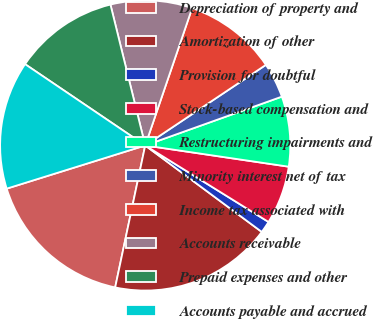<chart> <loc_0><loc_0><loc_500><loc_500><pie_chart><fcel>Depreciation of property and<fcel>Amortization of other<fcel>Provision for doubtful<fcel>Stock-based compensation and<fcel>Restructuring impairments and<fcel>Minority interest net of tax<fcel>Income tax associated with<fcel>Accounts receivable<fcel>Prepaid expenses and other<fcel>Accounts payable and accrued<nl><fcel>16.87%<fcel>18.16%<fcel>1.32%<fcel>6.5%<fcel>7.8%<fcel>3.91%<fcel>10.39%<fcel>9.09%<fcel>11.68%<fcel>14.28%<nl></chart> 